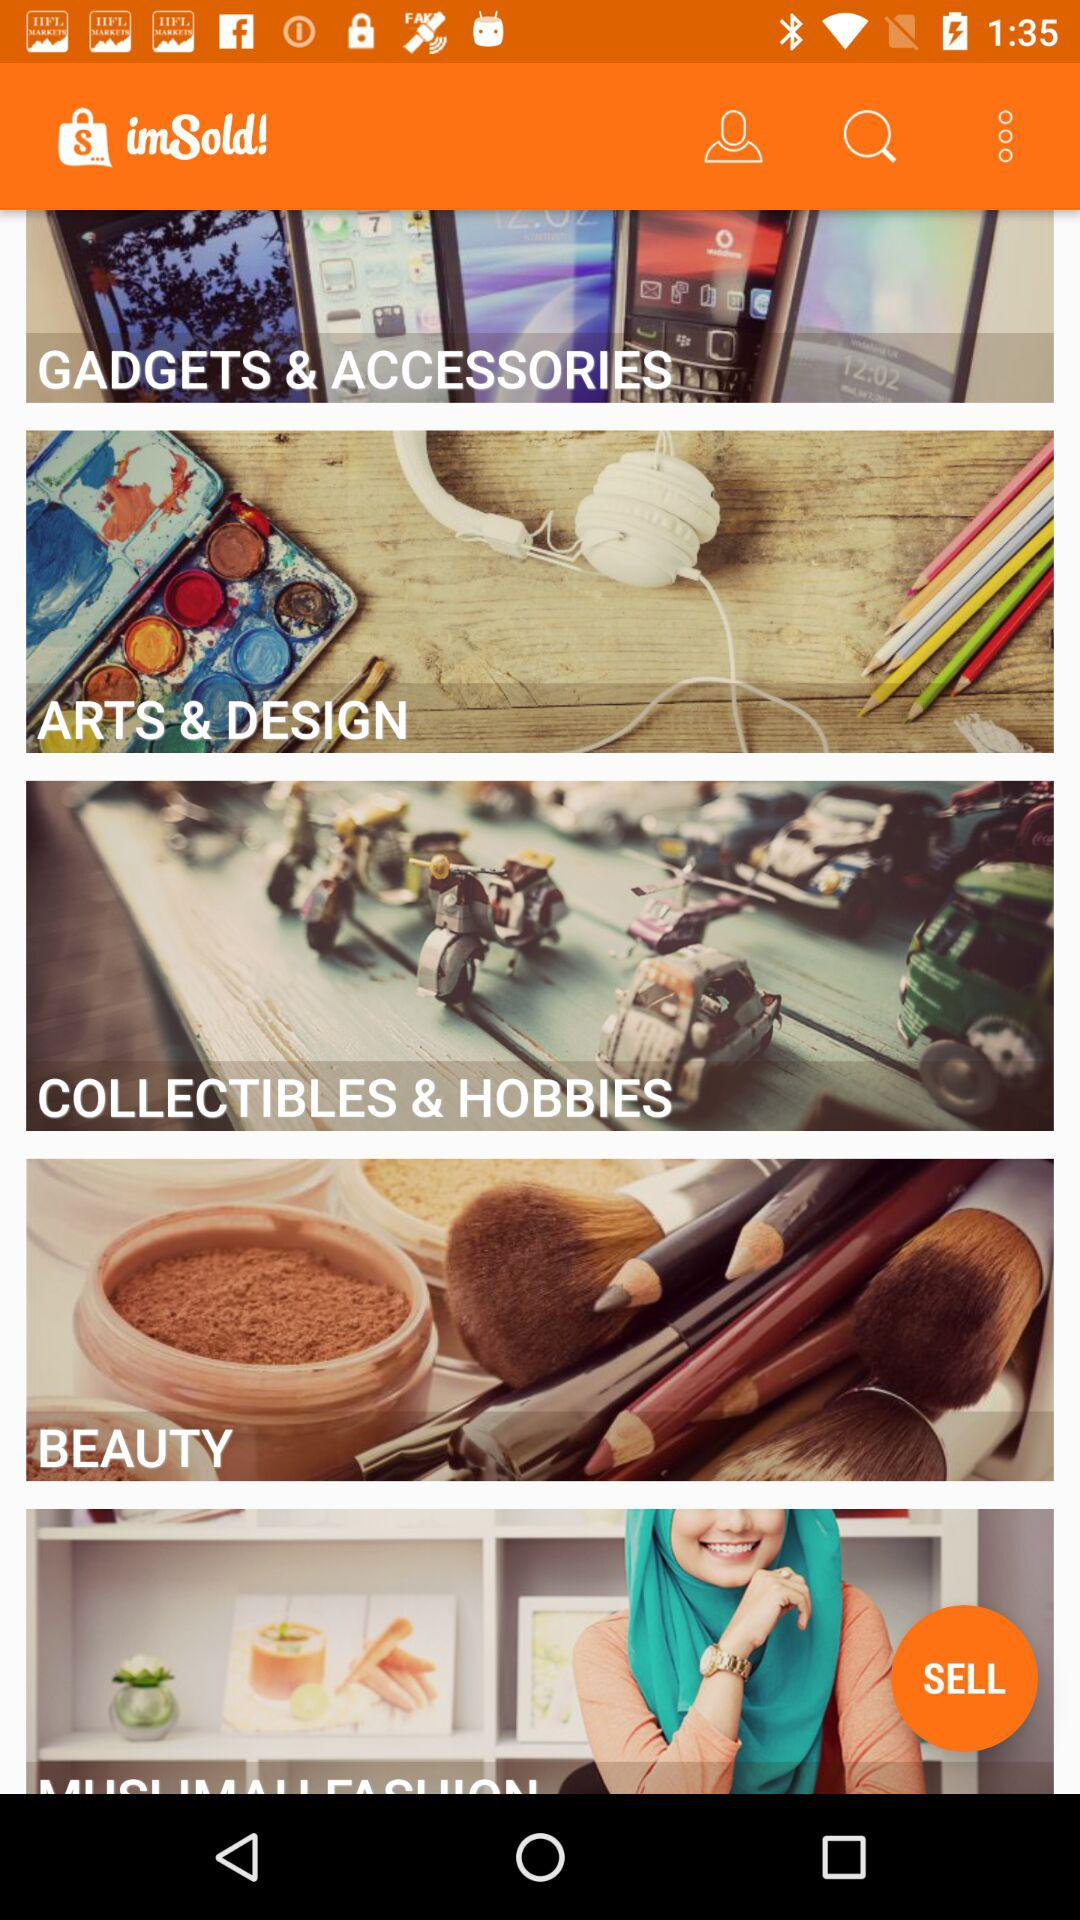What is the name of the application? The name of the application is "imSold". 